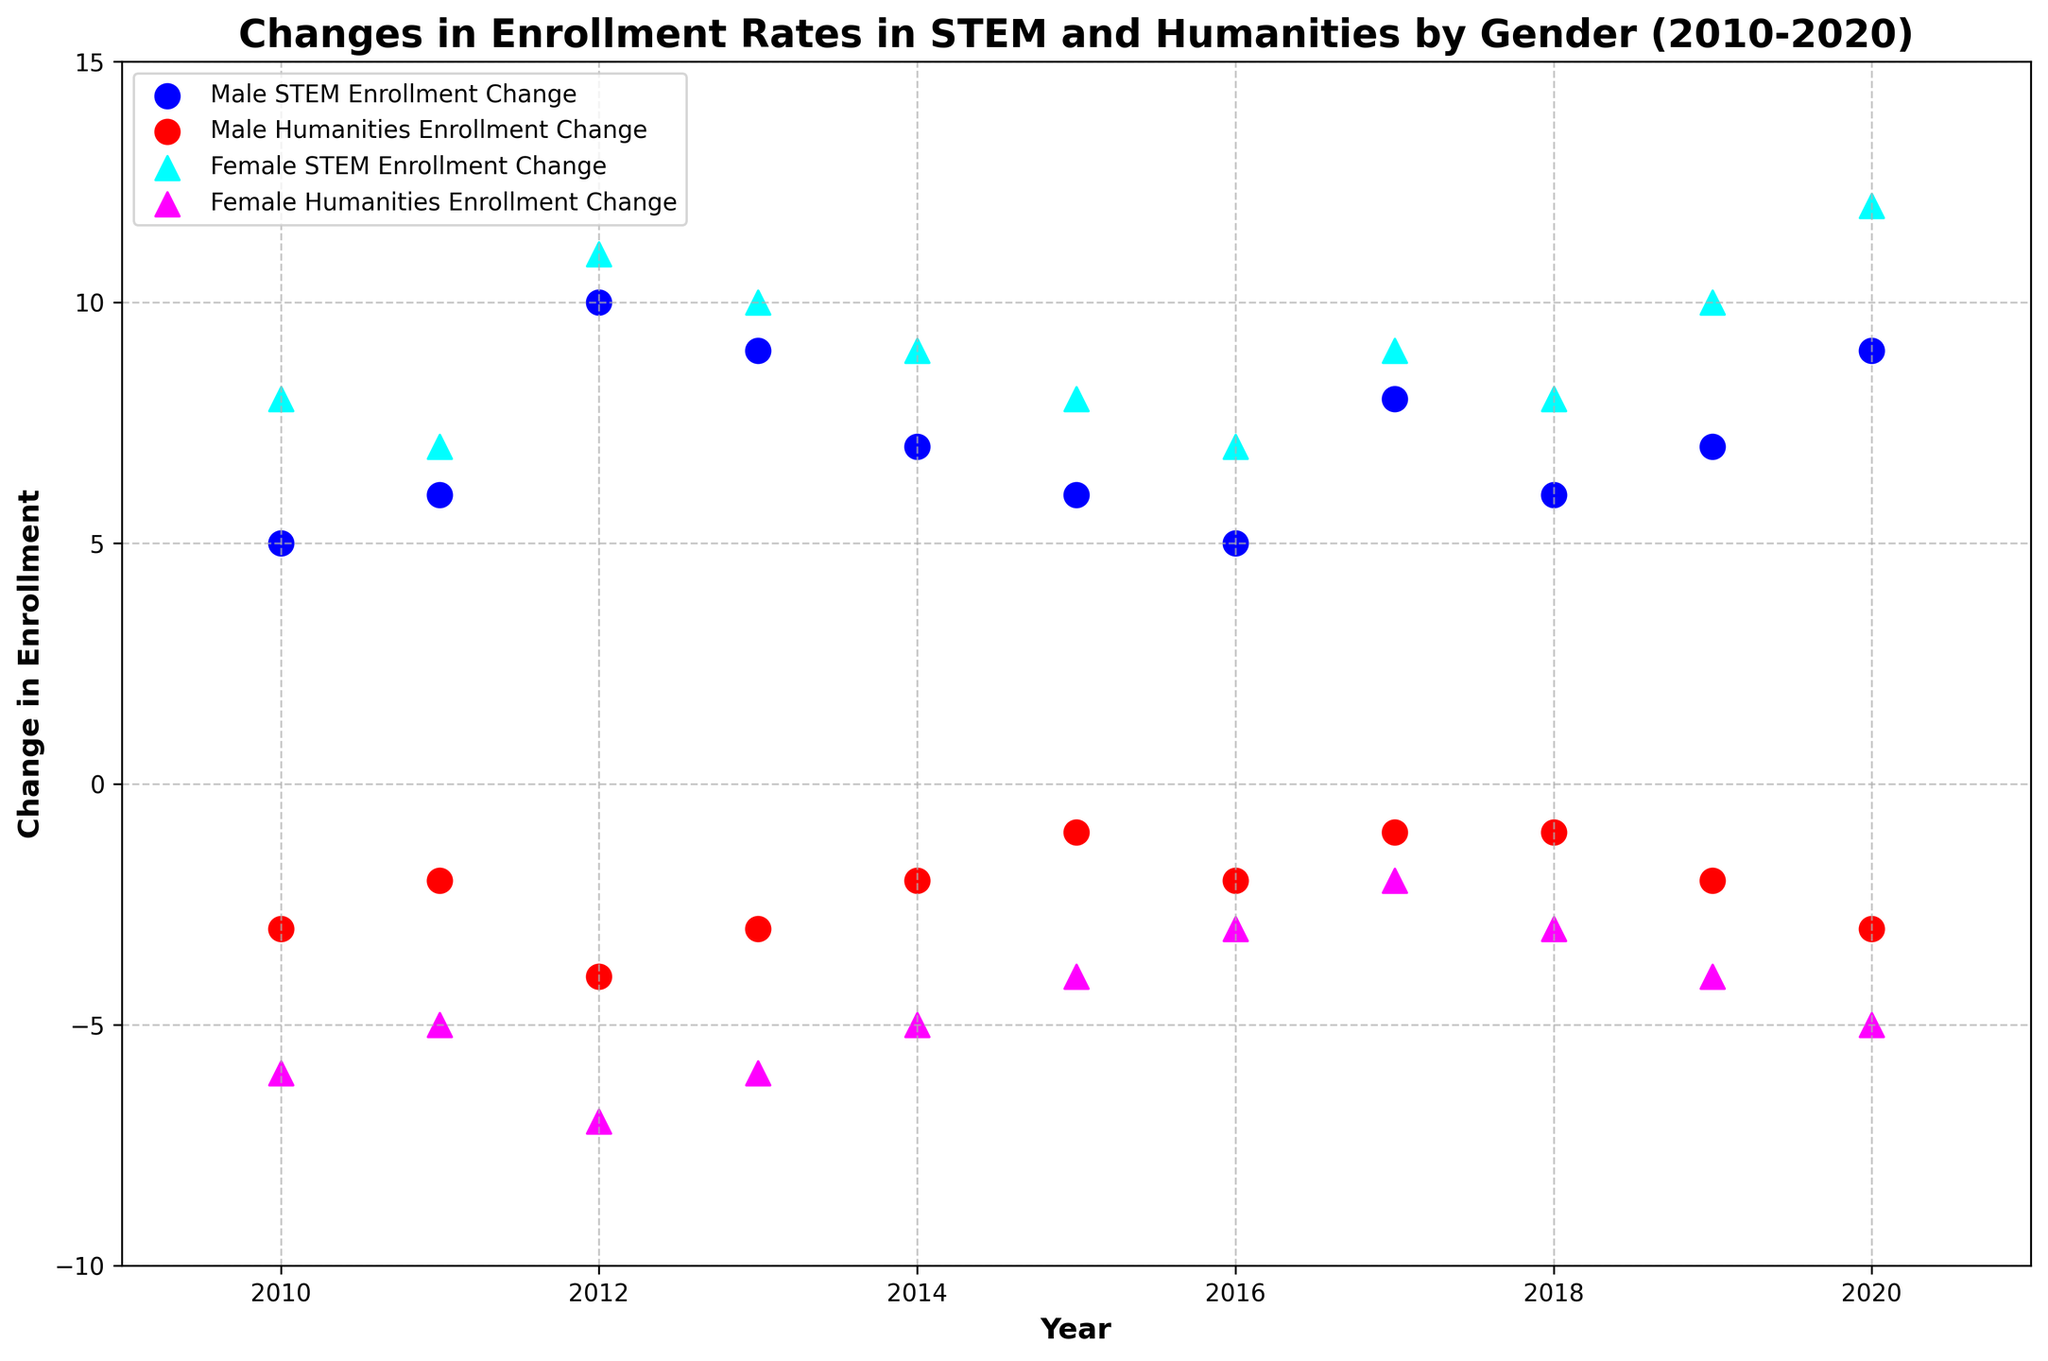Which gender had a higher change in STEM enrollment in 2020? To determine which gender had a higher change in STEM enrollment in 2020, look at the STEM enrollment change values for both males and females in that year. The male change is 9, and the female change is 12. 12 is higher than 9, so females had a higher change.
Answer: Female In which year did males have the lowest change in Humanities enrollment? Review the changes in Humanities enrollment for males across all years to identify the lowest value. The change values are -3, -2, -4, -3, -2, -1, -2, -1, -1, -2, -3. The lowest value is -4, which occurred in 2012.
Answer: 2012 How did the change in STEM enrollment differ between genders in 2015? Check the change in STEM enrollment values for both genders in 2015. Males had a change of 6, while females had a change of 8. So, the difference is \(8 - 6 = 2\).
Answer: 2 Across the entire period shown, which gender had the most consistent change in Humanities enrollment? Consistent change can be seen as smaller changes in values year to year. Comparing the values: For males, the changes are -3, -2, -4, -3, -2, -1, -2, -1, -1, -2, -3. For females, the changes are -6, -5, -7, -6, -5, -4, -3, -2, -3, -4, -5. Male values are generally closer to each other than female values, indicating more consistency.
Answer: Male What is the average change in STEM enrollment for females from 2010 to 2015? Calculate the sum of female STEM enrollment changes from 2010 to 2015: \(8 + 7 + 11 + 10 + 9 + 8 = 53\). There are 6 years in this range, so the average is \( 53/6 \approx 8.83 \).
Answer: 8.83 In which year was the change in Humanities enrollment for females equal to the change in Humanities enrollment for males? Compare the yearly changes in Humanities enrollment for both genders to find any matches. From 2010 to 2020, there is no year where the changes match exactly. A detailed comparison shows each pair of values (Female: -6, Male: -3), (Female: -5, Male: -2), etc., which are all different. Thus, they never match.
Answer: None Compare the STEM enrollment changes for males and females in 2014. Which gender had a higher change, and by how much? The 2014 values are 7 for males and 9 for females. Therefore, females had a higher change. The difference is \(9 - 7 = 2\).
Answer: Females by 2 Calculate the total change in Humanities enrollment for both genders over the period 2010-2020. Sum the changes for each gender separately and then add them up. For males: \(-3 + (-2) + (-4) + (-3) + (-2) + (-1) + (-2) + (-1) + (-1) + (-2) + (-3) = -26\). For females: \(-6 + (-5) + (-7) + (-6) + (-5) + (-4) + (-3) + (-2) + (-3) + (-4) + (-5) = -50\). Total change is \(-26 + (-50) = -76\).
Answer: -76 